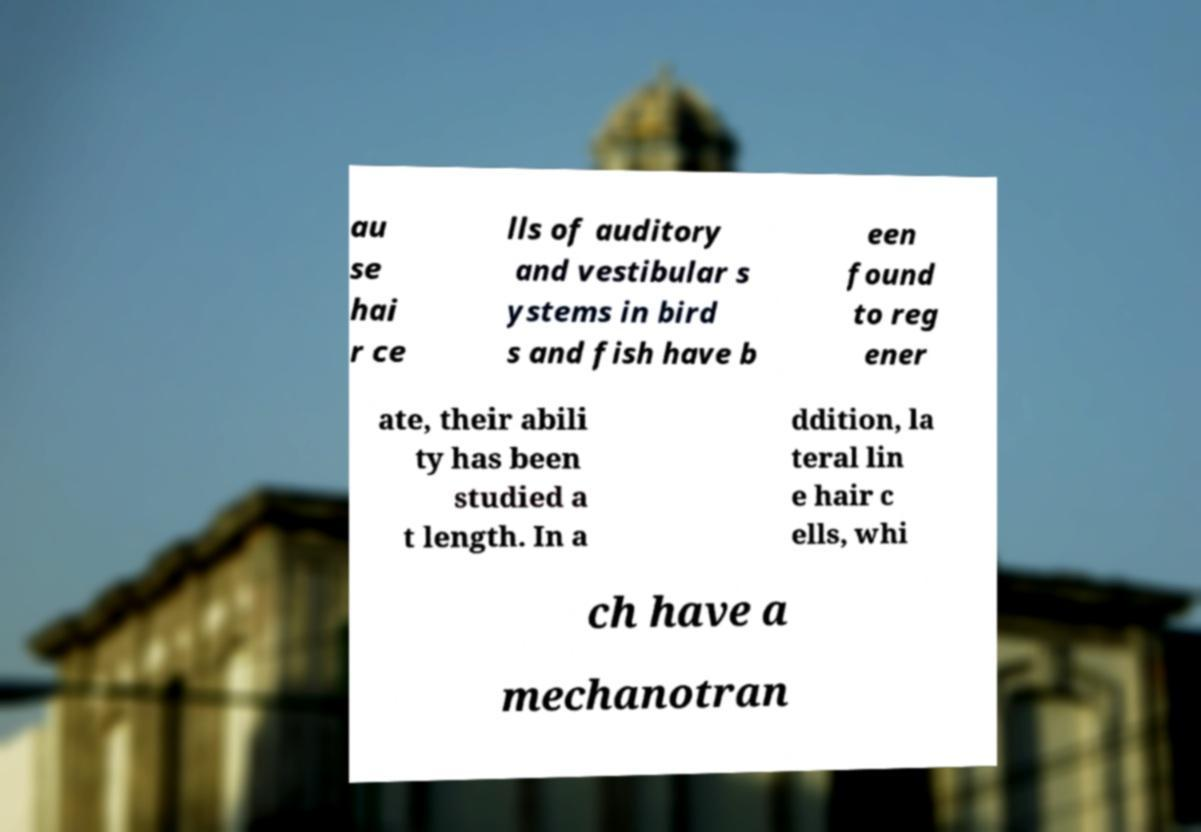Please identify and transcribe the text found in this image. au se hai r ce lls of auditory and vestibular s ystems in bird s and fish have b een found to reg ener ate, their abili ty has been studied a t length. In a ddition, la teral lin e hair c ells, whi ch have a mechanotran 